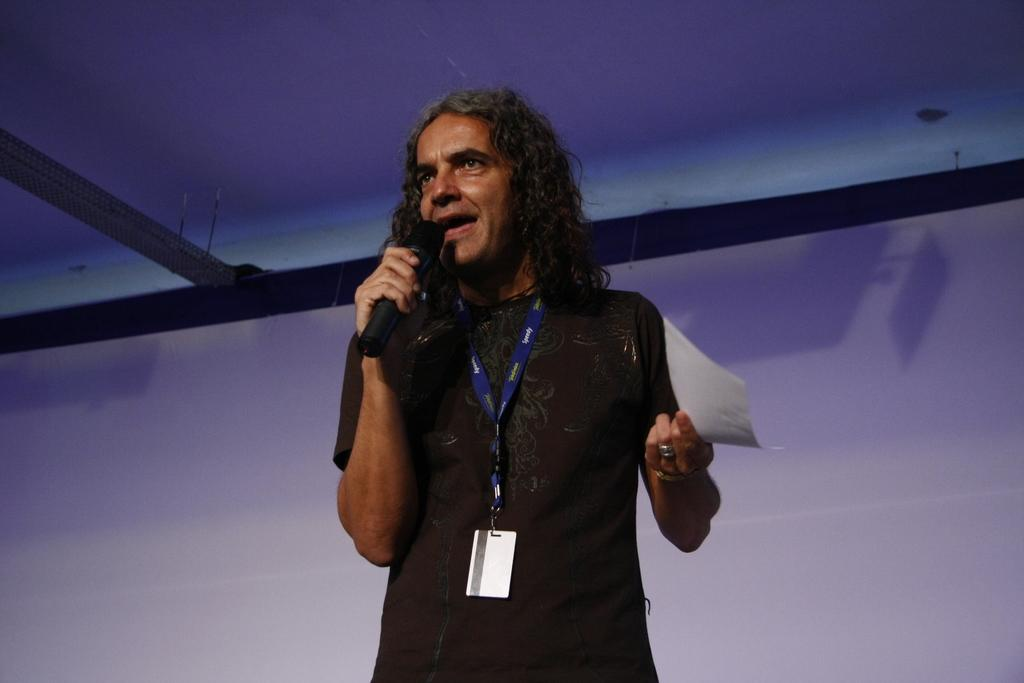What is the main subject of the image? There is a person in the image. What is the person doing in the image? The person is standing. What can be seen on the person's clothing? The person is wearing an identity card and a black color t-shirt. What objects is the person holding in the image? The person is holding a paper in one hand and a microphone in the other hand. What type of pain is the person experiencing in the image? There is no indication in the image that the person is experiencing any pain. What unit of measurement is being used to select the person in the image? There is no selection process or unit of measurement mentioned in the image. 